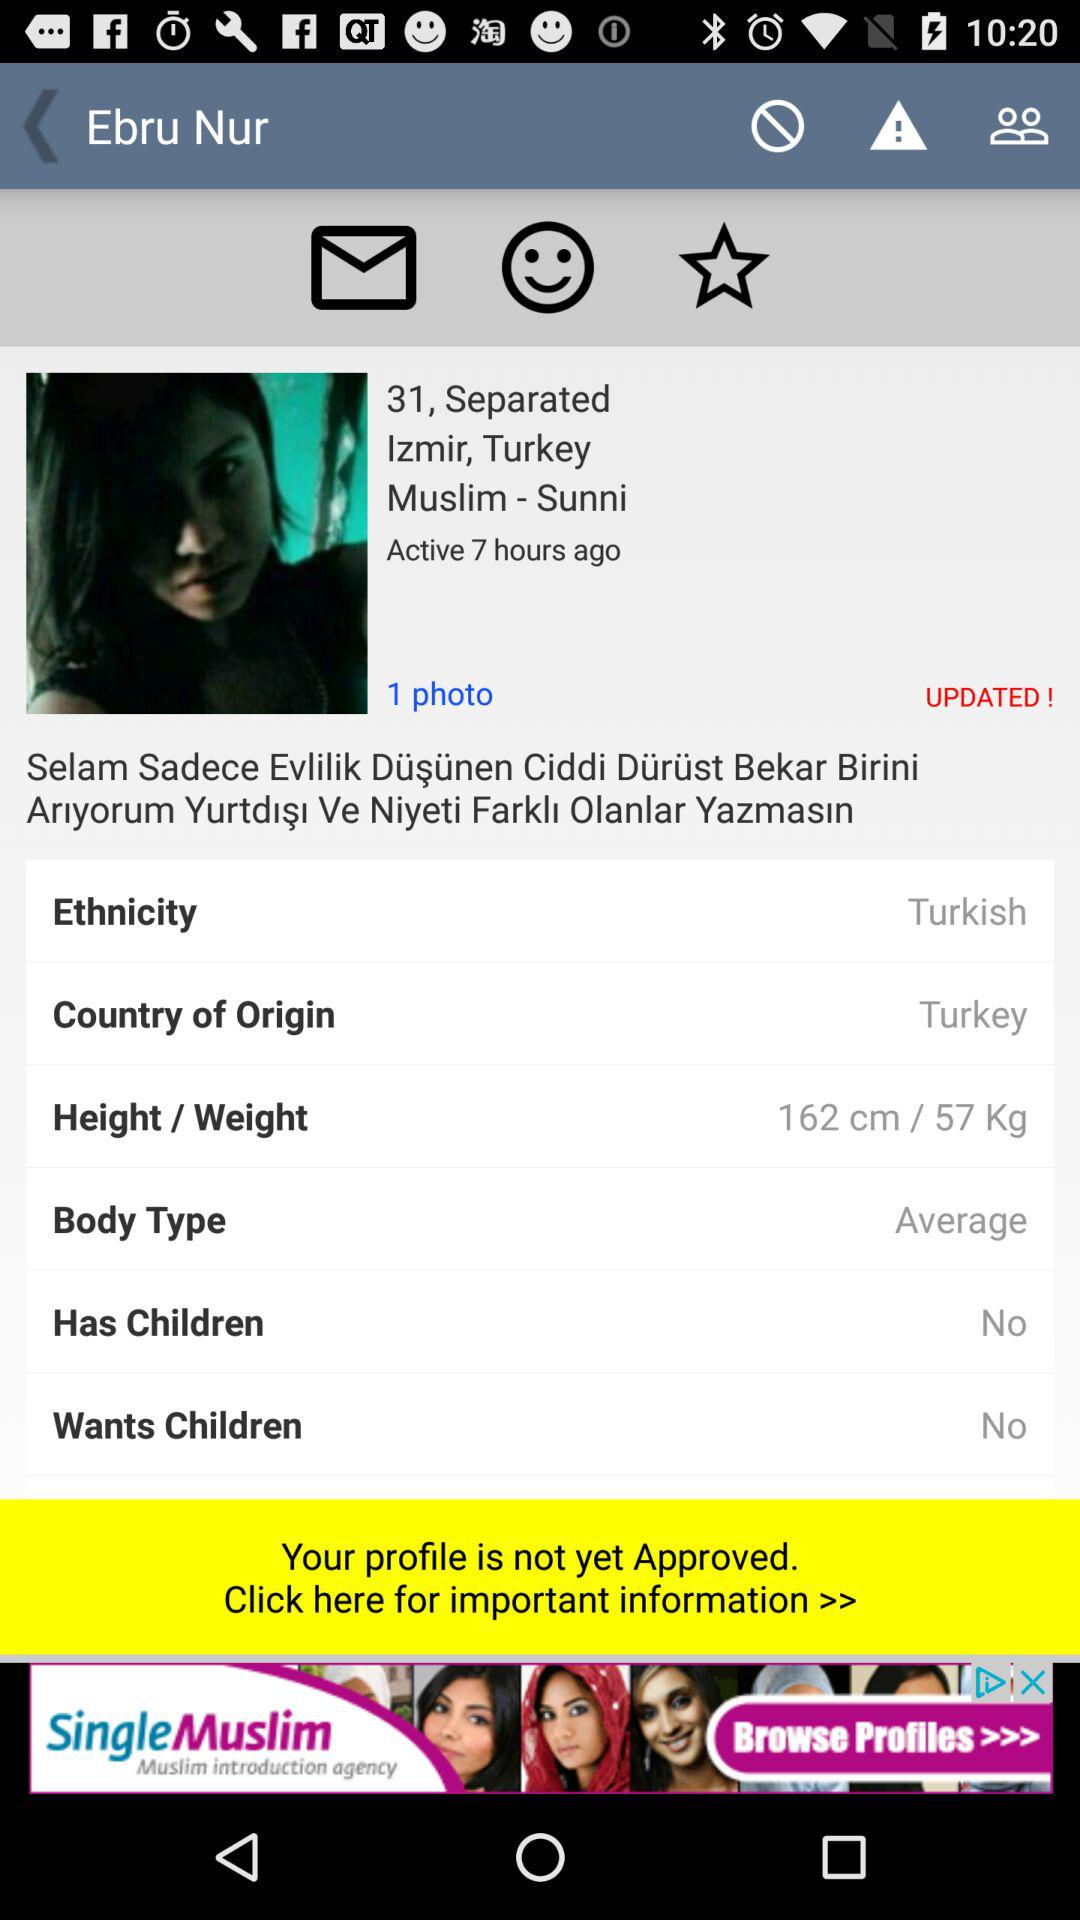What is the country of origin? The country of origin is Turkey. 